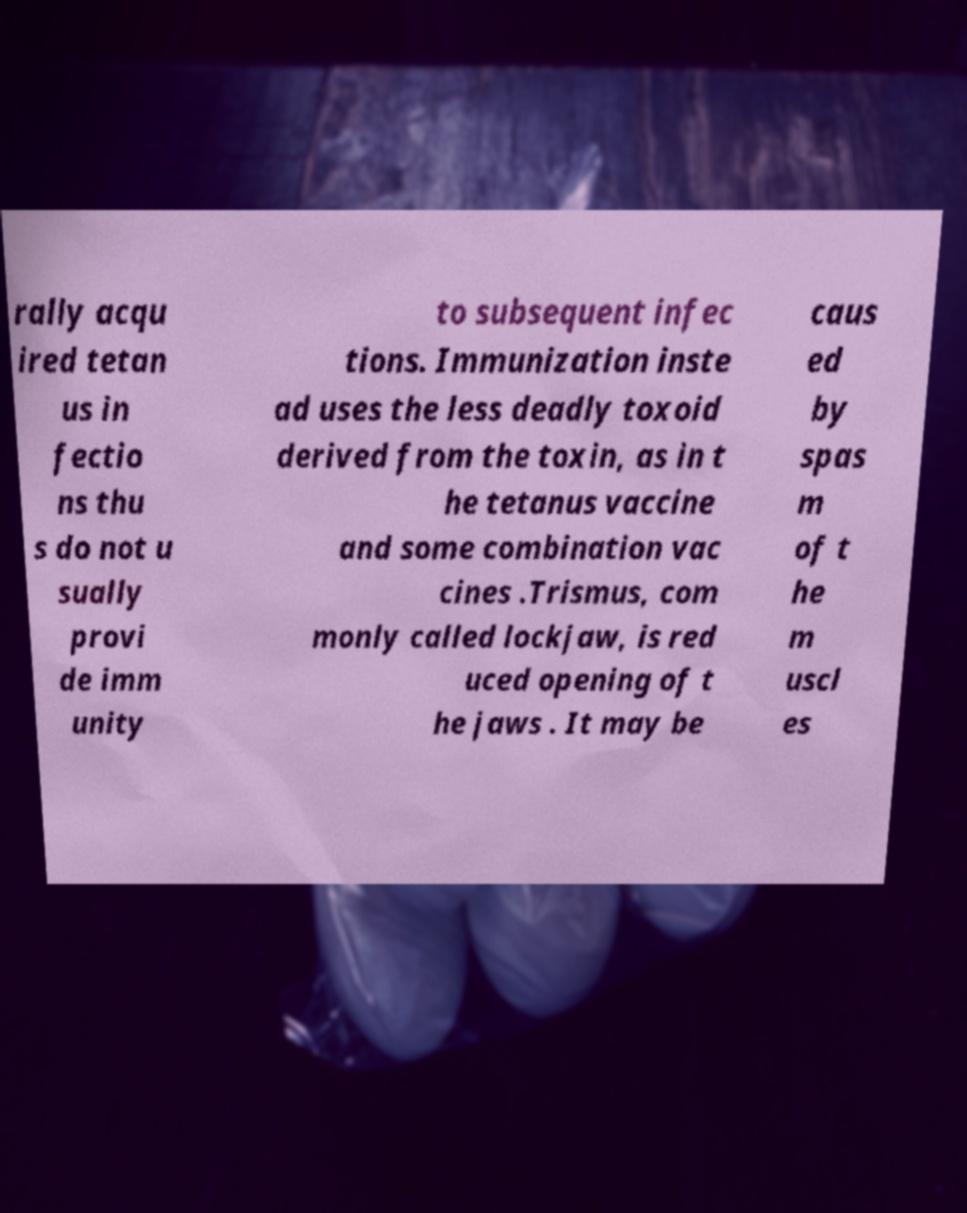Please identify and transcribe the text found in this image. rally acqu ired tetan us in fectio ns thu s do not u sually provi de imm unity to subsequent infec tions. Immunization inste ad uses the less deadly toxoid derived from the toxin, as in t he tetanus vaccine and some combination vac cines .Trismus, com monly called lockjaw, is red uced opening of t he jaws . It may be caus ed by spas m of t he m uscl es 